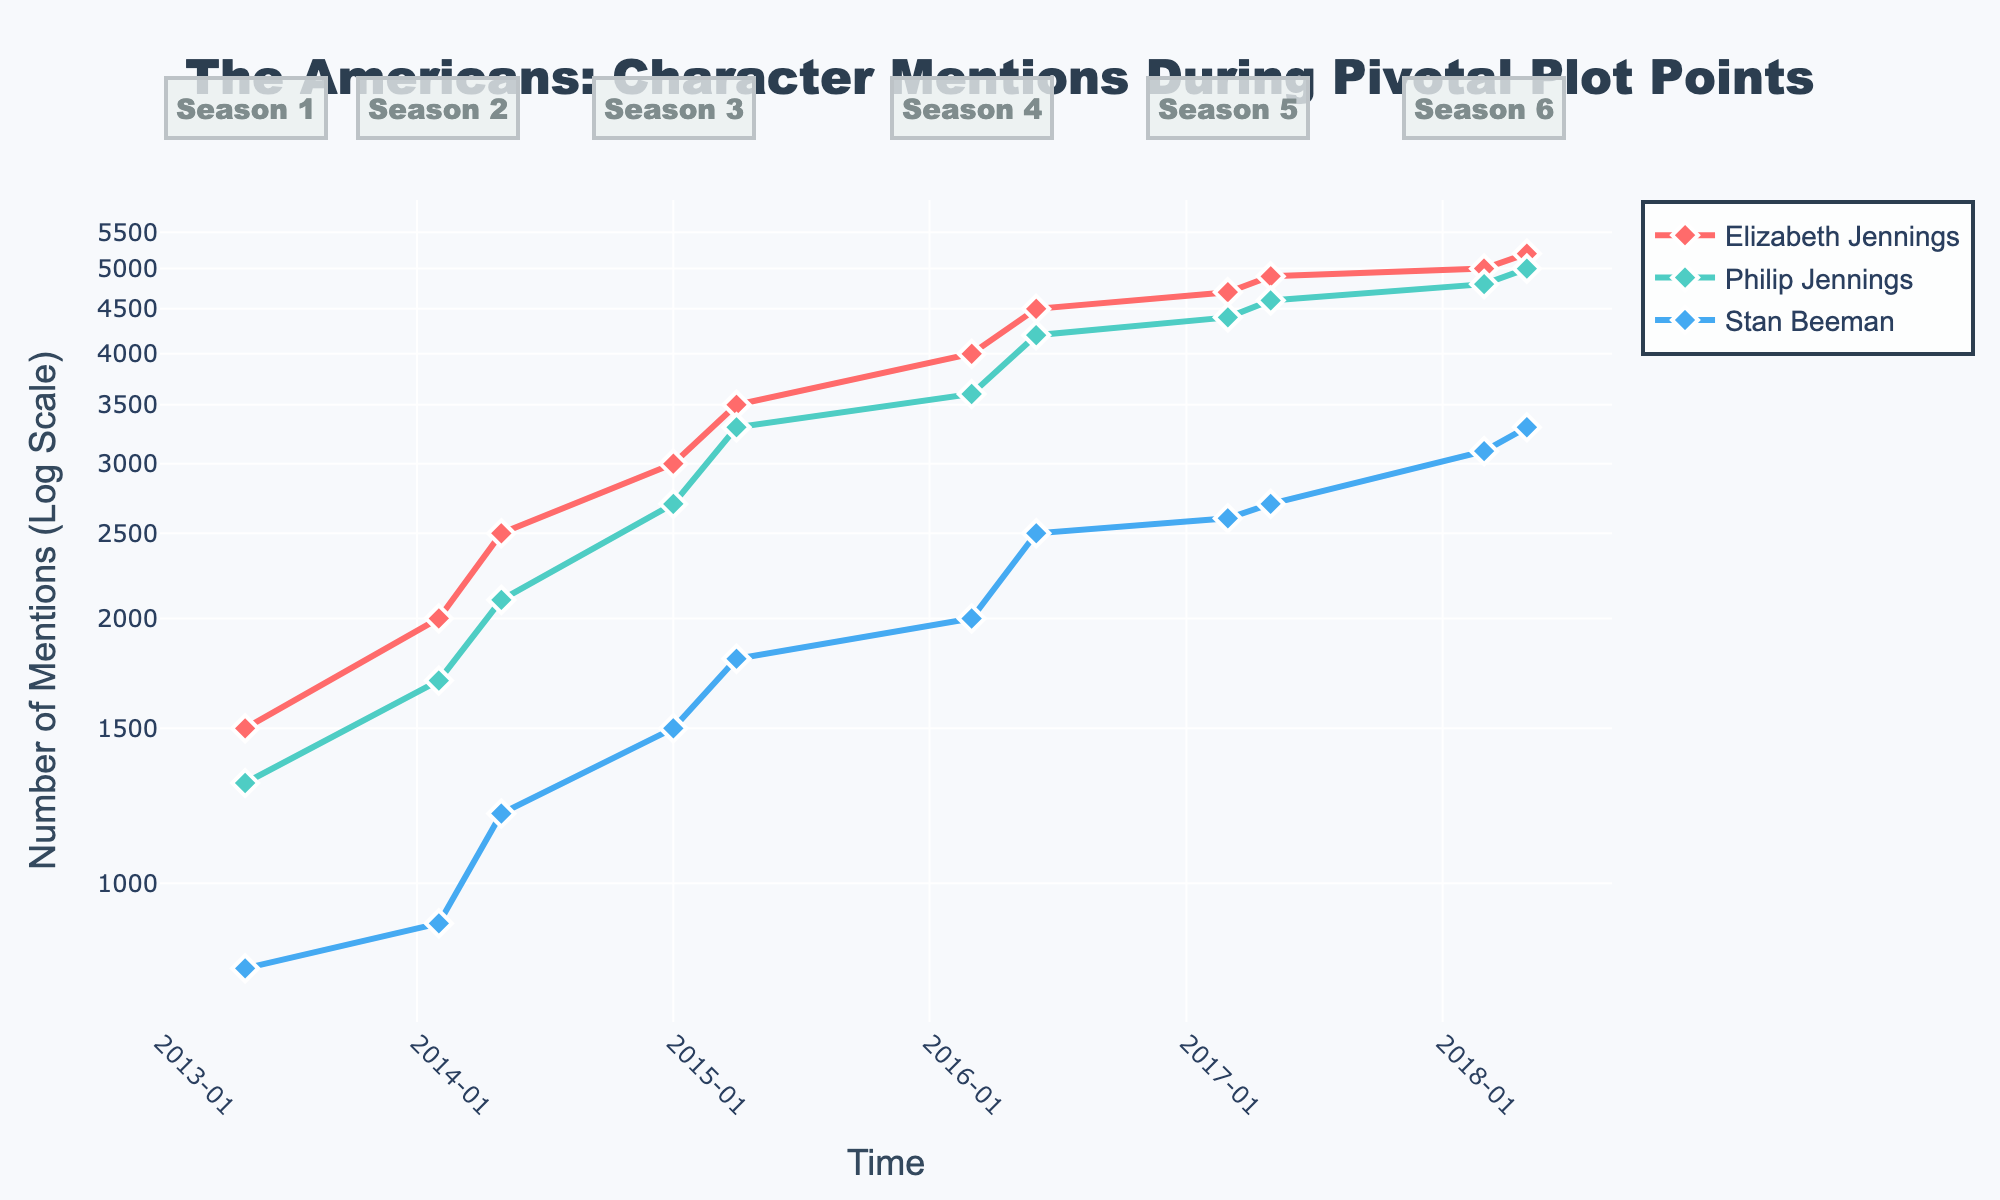What pivotal plot point had the highest number of mentions for Elizabeth Jennings? First, look at the y-axis for the number of mentions plotted on a log scale. For Elizabeth Jennings, find the highest point. The data point is labeled 'Season 6 Finale' on the x-axis, and the y-axis value for mentions is the highest for this character.
Answer: Season 6 Finale During which season premiere did Philip Jennings receive the least mentions? To answer, identify all the season premiere points for Philip Jennings. Then, compare the number of mentions. The lowest mentions during a season premiere are found at 'Season 2 Premiere' on the x-axis.
Answer: Season 2 Premiere By how much did Stan Beeman's mentions increase from the Season 5 Finale to the Season 6 Premiere? Compare the number of mentions for Stan Beeman at the 'Season 5 Finale' and 'Season 6 Premiere' points. Subtract the 'Season 5 Finale' value (2700 mentions) from the 'Season 6 Premiere' value (3100 mentions).
Answer: 400 Which character had the steepest increase in social media mentions from the Season 1 Finale to the Season 2 Finale? Look at the y-axis values for the Season 1 Finale and Season 2 Finale for each character. Calculate the difference for each. Elizabeth Jennings' mentions increased from 1500 to 2500 (1000 mentions increase), Philip Jennings from 1300 to 2100 (800 mentions increase), and Stan Beeman from 800 to 1200 (400 mentions increase). The steepest increase is for Elizabeth Jennings.
Answer: Elizabeth Jennings What is the overall trend in mentions for Stan Beeman from Season 1 to Season 6? Observe the trend of Stan Beeman's mentions from Season 1 through to Season 6 on the log scale y-axis. Notice the gradual increase over time with each pivotal plot point, indicating an upward trend.
Answer: Increasing trend How do the mentions for Elizabeth Jennings and Philip Jennings compare during the Season 6 Finale? Look at the 'Season 6 Finale' on the x-axis. Compare Elizabeth Jennings' mentions (5200) to Philip Jennings' mentions (5000) using the y-axis. Elizabeth Jennings has more mentions than Philip Jennings.
Answer: Elizabeth Jennings had more mentions What was the difference in mentions between the Season 4 Premiere and Season 4 Finale for Philip Jennings? Locate the 'Season 4 Premiere' and 'Season 4 Finale' points for Philip Jennings. Subtract the Season 4 Premiere value (3600 mentions) from the Season 4 Finale value (4200 mentions).
Answer: 600 Considering the pivotal plot points, which character consistently had the highest mentions at each finale? For each season finale point, compare the mentions for Elizabeth Jennings, Philip Jennings, and Stan Beeman. Across all finales, Elizabeth Jennings consistently had the highest mentions.
Answer: Elizabeth Jennings What was the average number of mentions for Philip Jennings during season premieres? Identify the number of mentions for Philip Jennings during each season premiere. Add them up: 1700 (Season 2), 2700 (Season 3), 3600 (Season 4), 4400 (Season 5), and 4800 (Season 6). The total is 17200. Divide by the number of seasons, 5.
Answer: 3440 Which character received the least mentions during the Season 3 Finale? Look at the 'Season 3 Finale' on the x-axis and compare the mentions of all three characters. Stan Beeman received the least mentions with 1800 mentions.
Answer: Stan Beeman 